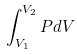Convert formula to latex. <formula><loc_0><loc_0><loc_500><loc_500>\int _ { V _ { 1 } } ^ { V _ { 2 } } P d V</formula> 